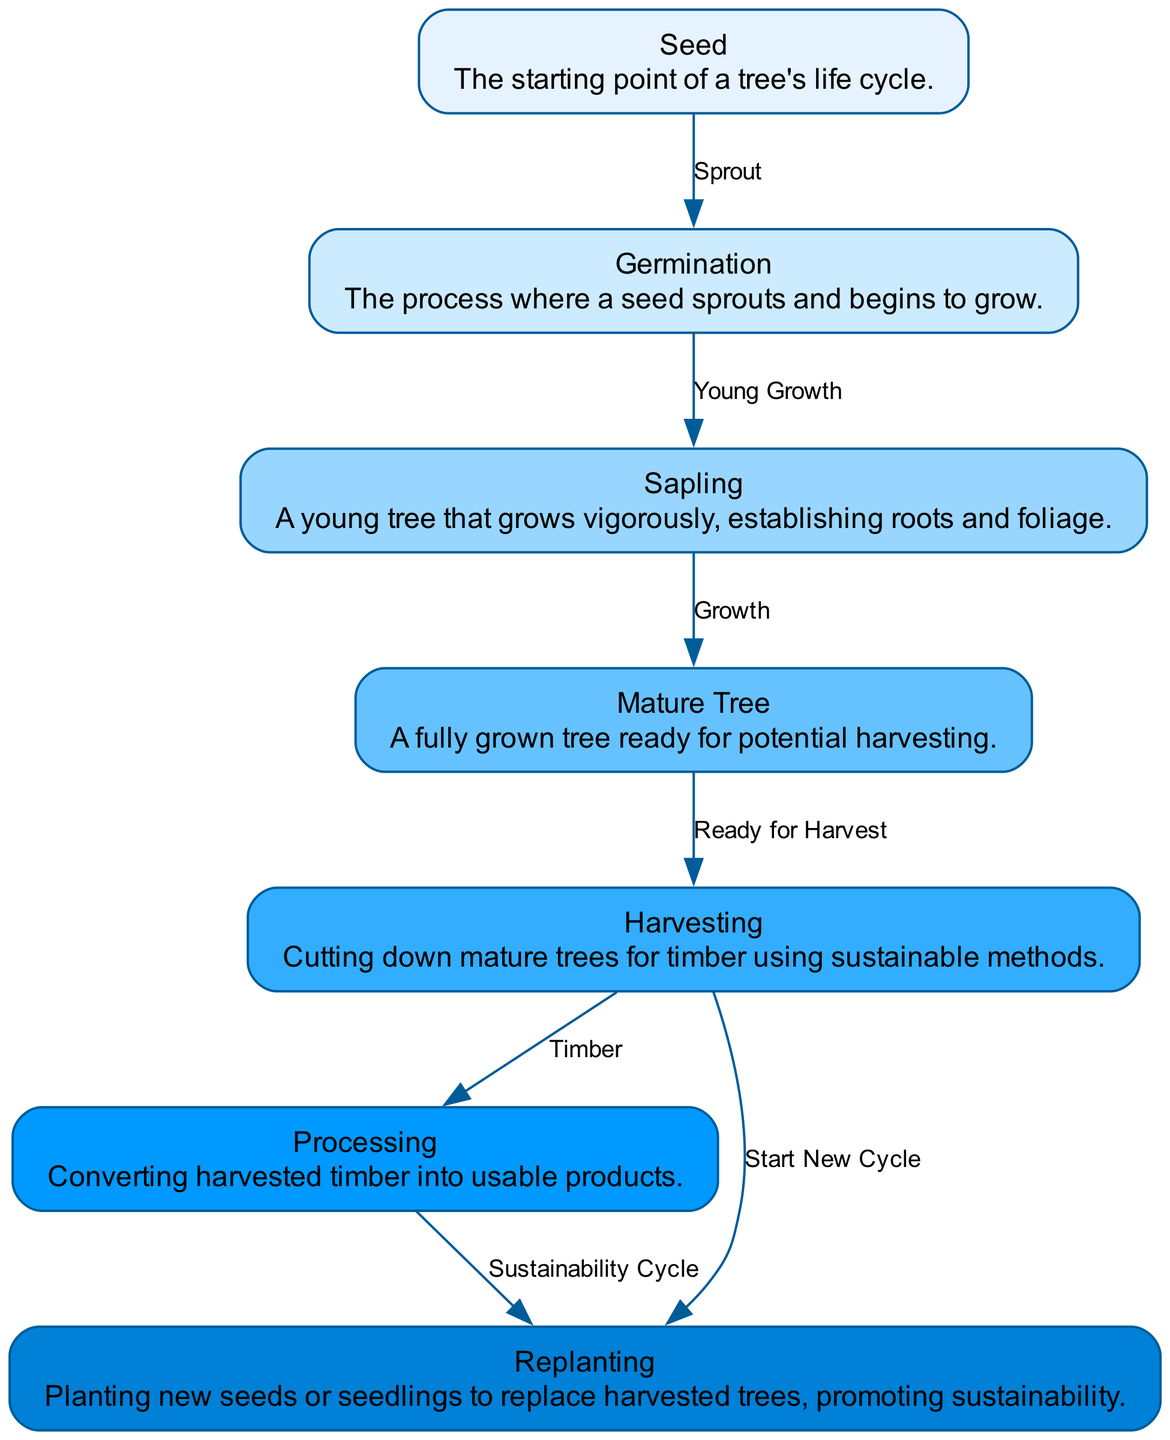What is the starting point of a tree's life cycle? The diagram indicates that the life cycle of a tree begins with the "Seed," which is identified as the starting point in the description of the node labeled "Seed."
Answer: Seed How many nodes are present in the diagram? The diagram consists of seven distinct nodes representing different stages in the tree's lifecycle, as listed in the provided data.
Answer: 7 What comes after the "Germination" stage? The edge labeled "Young Growth" connects the "Germination" node to the "Sapling" node, indicating that "Sapling" is the subsequent stage following "Germination."
Answer: Sapling What does "Mature Tree" prepare for in this lifecycle? The diagram shows that the "Mature Tree" node is linked to the "Harvesting" node through the edge labeled "Ready for Harvest," indicating its readiness for harvesting.
Answer: Harvesting Which process follows "Harvesting"? The edge labeled "Timber" connects "Harvesting" to "Processing," indicating that the process that follows harvesting is processing the timber.
Answer: Processing What is the sustainability practice recommended after "Processing"? After processing, the diagram illustrates a path to the "Replanting" node through the edge labeled "Sustainability Cycle," which emphasizes the importance of replanting to maintain sustainability.
Answer: Replanting How many edges connect nodes in total? The diagram contains six edges, which represent the connections and relationships between the seven nodes, as detailed in the data.
Answer: 6 What is the label for the edge between "harvesting" and "replanting"? The edge connecting "harvesting" to "replanting" is labeled "Start New Cycle," indicating that this action initiates a new growth cycle.
Answer: Start New Cycle Explain the role of "Replanting" in the lifecycle. "Replanting" is positioned after both "Processing" and directly after "Harvesting," suggesting its vital role in sustaining the lifecycle by ensuring that new trees are planted to replace those that are harvested, promoting environmental sustainability.
Answer: Sustainability 